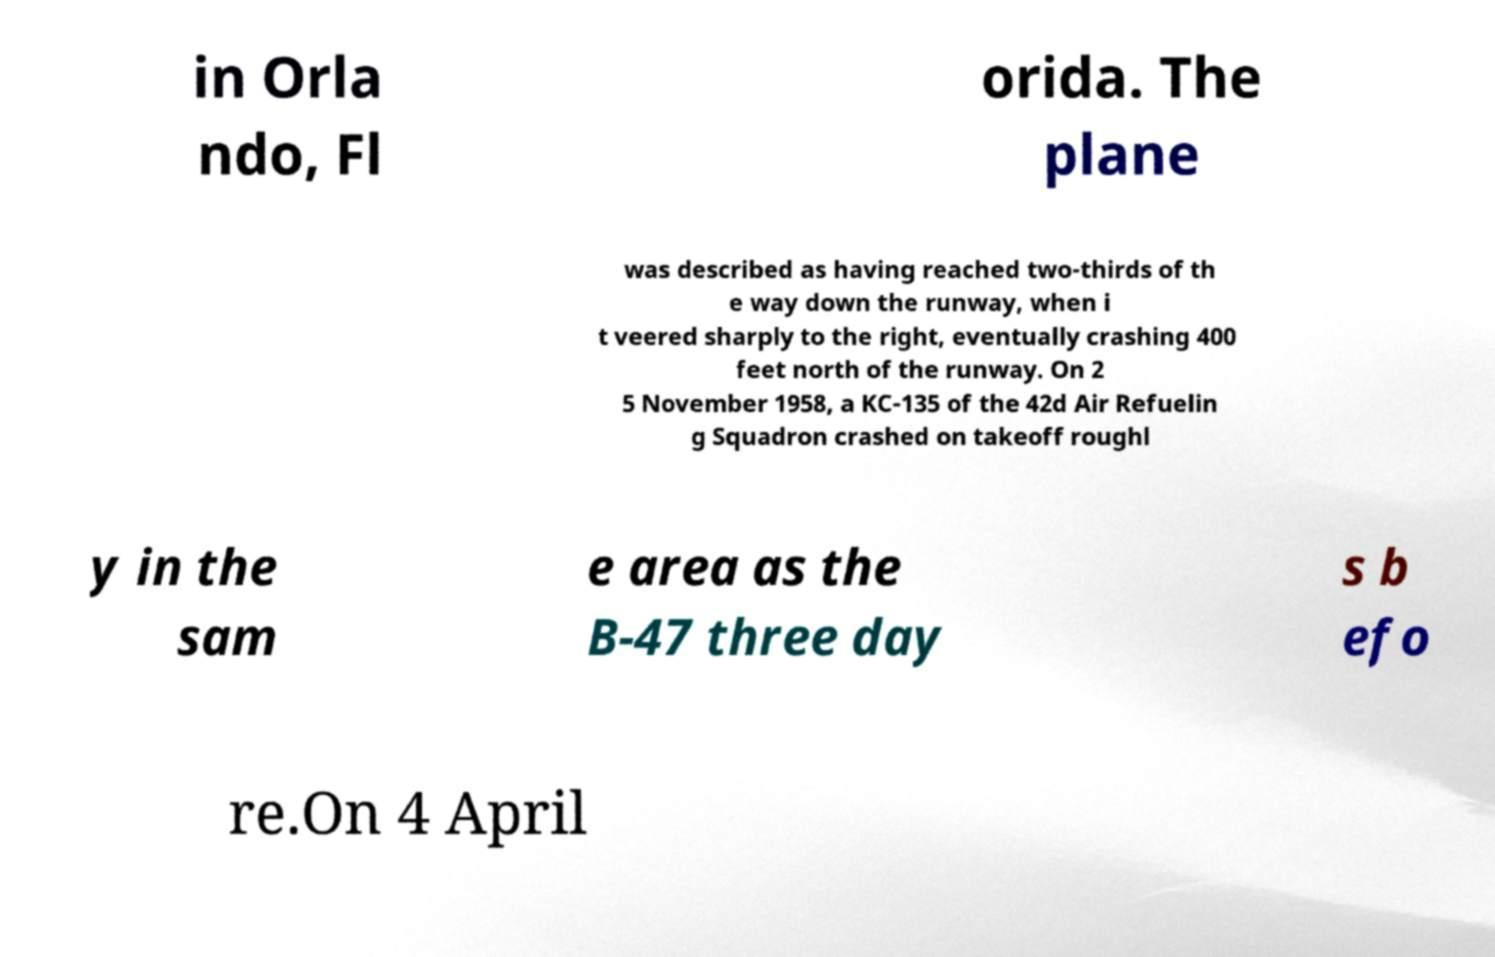Can you read and provide the text displayed in the image?This photo seems to have some interesting text. Can you extract and type it out for me? in Orla ndo, Fl orida. The plane was described as having reached two-thirds of th e way down the runway, when i t veered sharply to the right, eventually crashing 400 feet north of the runway. On 2 5 November 1958, a KC-135 of the 42d Air Refuelin g Squadron crashed on takeoff roughl y in the sam e area as the B-47 three day s b efo re.On 4 April 